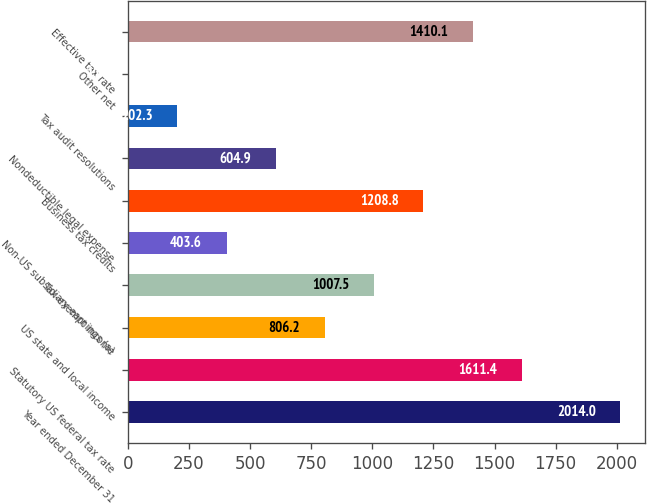Convert chart. <chart><loc_0><loc_0><loc_500><loc_500><bar_chart><fcel>Year ended December 31<fcel>Statutory US federal tax rate<fcel>US state and local income<fcel>Tax-exempt income<fcel>Non-US subsidiary earnings (a)<fcel>Business tax credits<fcel>Nondeductible legal expense<fcel>Tax audit resolutions<fcel>Other net<fcel>Effective tax rate<nl><fcel>2014<fcel>1611.4<fcel>806.2<fcel>1007.5<fcel>403.6<fcel>1208.8<fcel>604.9<fcel>202.3<fcel>1<fcel>1410.1<nl></chart> 